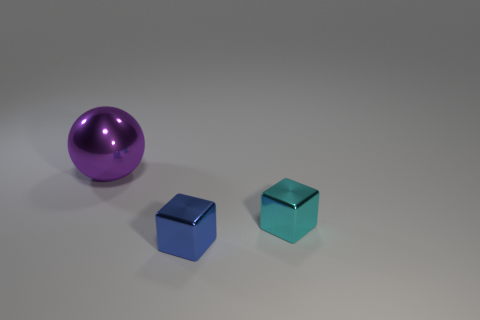What number of other objects are there of the same size as the purple ball?
Your answer should be compact. 0. What is the material of the other small thing that is the same shape as the small blue thing?
Provide a short and direct response. Metal. How many cubes are big purple objects or tiny red objects?
Provide a short and direct response. 0. What number of things are behind the cyan cube and in front of the large object?
Offer a terse response. 0. Is the number of tiny cyan blocks that are in front of the cyan block the same as the number of shiny cubes that are in front of the large metallic ball?
Ensure brevity in your answer.  No. There is a tiny object that is to the right of the small blue block; is its shape the same as the large purple shiny object?
Your response must be concise. No. There is a shiny object that is left of the metal thing in front of the tiny cube behind the blue block; what shape is it?
Offer a very short reply. Sphere. What material is the object that is both to the left of the cyan block and in front of the purple metallic thing?
Keep it short and to the point. Metal. Are there fewer blue metal things than small metallic things?
Keep it short and to the point. Yes. There is a blue object; is its shape the same as the metallic object left of the blue thing?
Make the answer very short. No. 